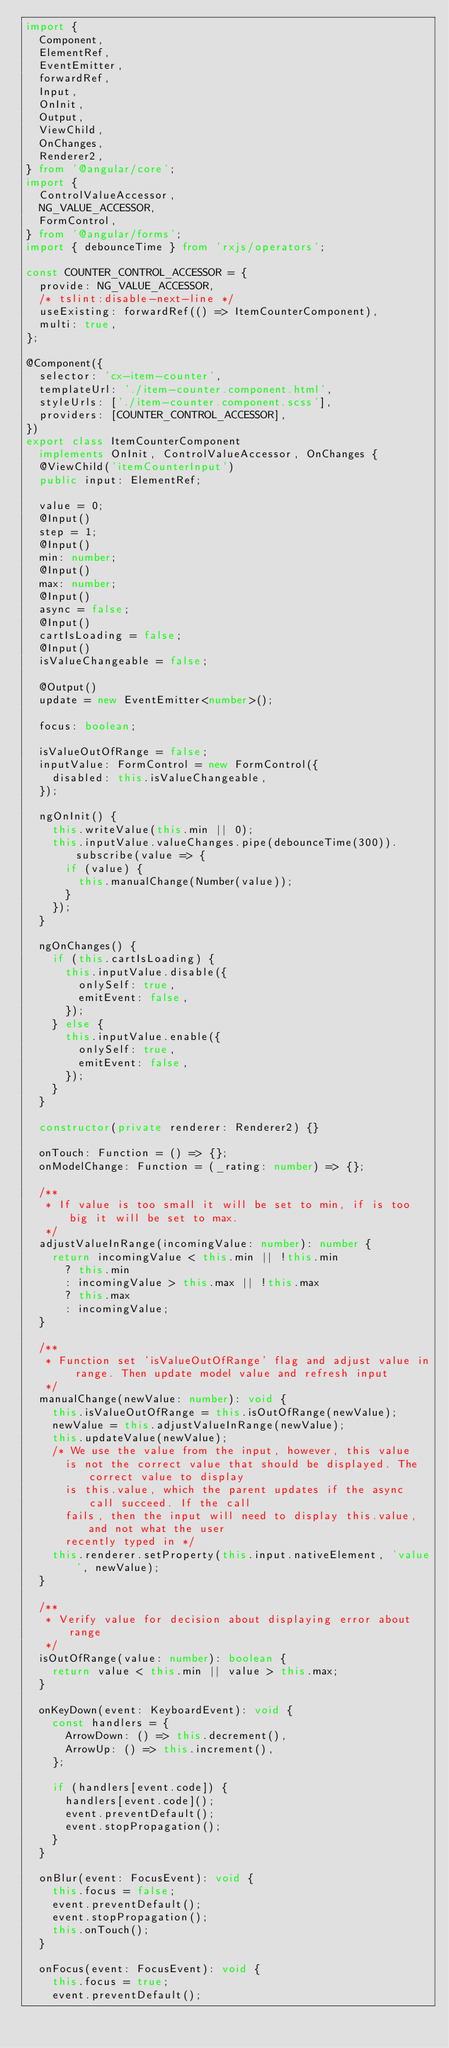Convert code to text. <code><loc_0><loc_0><loc_500><loc_500><_TypeScript_>import {
  Component,
  ElementRef,
  EventEmitter,
  forwardRef,
  Input,
  OnInit,
  Output,
  ViewChild,
  OnChanges,
  Renderer2,
} from '@angular/core';
import {
  ControlValueAccessor,
  NG_VALUE_ACCESSOR,
  FormControl,
} from '@angular/forms';
import { debounceTime } from 'rxjs/operators';

const COUNTER_CONTROL_ACCESSOR = {
  provide: NG_VALUE_ACCESSOR,
  /* tslint:disable-next-line */
  useExisting: forwardRef(() => ItemCounterComponent),
  multi: true,
};

@Component({
  selector: 'cx-item-counter',
  templateUrl: './item-counter.component.html',
  styleUrls: ['./item-counter.component.scss'],
  providers: [COUNTER_CONTROL_ACCESSOR],
})
export class ItemCounterComponent
  implements OnInit, ControlValueAccessor, OnChanges {
  @ViewChild('itemCounterInput')
  public input: ElementRef;

  value = 0;
  @Input()
  step = 1;
  @Input()
  min: number;
  @Input()
  max: number;
  @Input()
  async = false;
  @Input()
  cartIsLoading = false;
  @Input()
  isValueChangeable = false;

  @Output()
  update = new EventEmitter<number>();

  focus: boolean;

  isValueOutOfRange = false;
  inputValue: FormControl = new FormControl({
    disabled: this.isValueChangeable,
  });

  ngOnInit() {
    this.writeValue(this.min || 0);
    this.inputValue.valueChanges.pipe(debounceTime(300)).subscribe(value => {
      if (value) {
        this.manualChange(Number(value));
      }
    });
  }

  ngOnChanges() {
    if (this.cartIsLoading) {
      this.inputValue.disable({
        onlySelf: true,
        emitEvent: false,
      });
    } else {
      this.inputValue.enable({
        onlySelf: true,
        emitEvent: false,
      });
    }
  }

  constructor(private renderer: Renderer2) {}

  onTouch: Function = () => {};
  onModelChange: Function = (_rating: number) => {};

  /**
   * If value is too small it will be set to min, if is too big it will be set to max.
   */
  adjustValueInRange(incomingValue: number): number {
    return incomingValue < this.min || !this.min
      ? this.min
      : incomingValue > this.max || !this.max
      ? this.max
      : incomingValue;
  }

  /**
   * Function set 'isValueOutOfRange' flag and adjust value in range. Then update model value and refresh input
   */
  manualChange(newValue: number): void {
    this.isValueOutOfRange = this.isOutOfRange(newValue);
    newValue = this.adjustValueInRange(newValue);
    this.updateValue(newValue);
    /* We use the value from the input, however, this value
      is not the correct value that should be displayed. The correct value to display
      is this.value, which the parent updates if the async call succeed. If the call
      fails, then the input will need to display this.value, and not what the user
      recently typed in */
    this.renderer.setProperty(this.input.nativeElement, 'value', newValue);
  }

  /**
   * Verify value for decision about displaying error about range
   */
  isOutOfRange(value: number): boolean {
    return value < this.min || value > this.max;
  }

  onKeyDown(event: KeyboardEvent): void {
    const handlers = {
      ArrowDown: () => this.decrement(),
      ArrowUp: () => this.increment(),
    };

    if (handlers[event.code]) {
      handlers[event.code]();
      event.preventDefault();
      event.stopPropagation();
    }
  }

  onBlur(event: FocusEvent): void {
    this.focus = false;
    event.preventDefault();
    event.stopPropagation();
    this.onTouch();
  }

  onFocus(event: FocusEvent): void {
    this.focus = true;
    event.preventDefault();</code> 